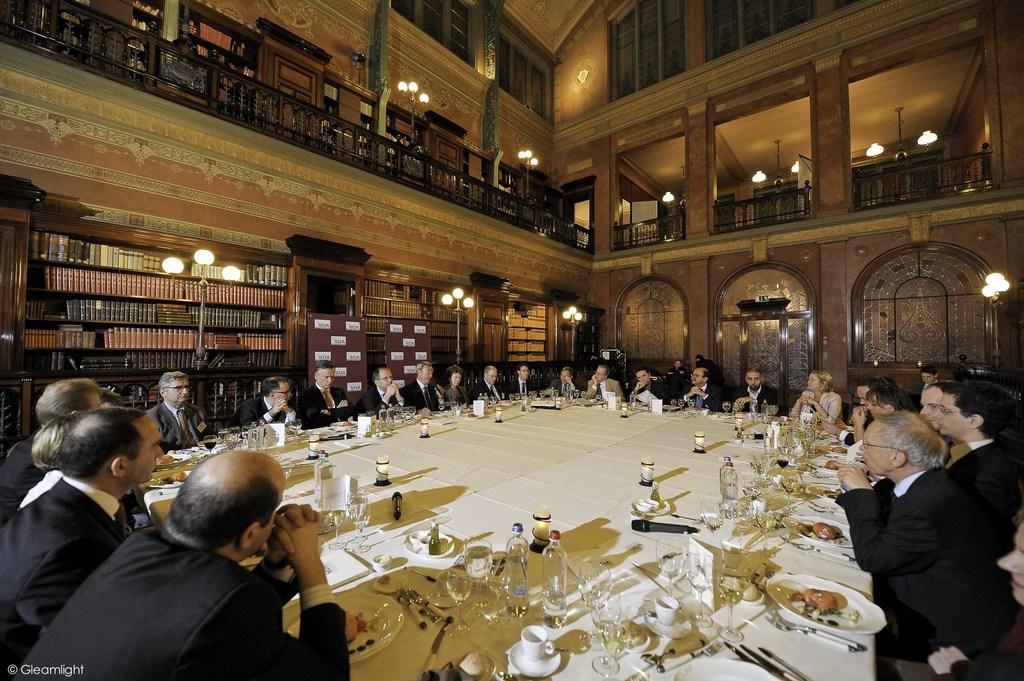How would you summarize this image in a sentence or two? In the center of the image there is a big table around which there are many people sitting. On the table there are many objects like bottle,glass,spoons,plates. At the background of the image there is building with a balcony. At the left side of the image there is text printed at the bottom. 